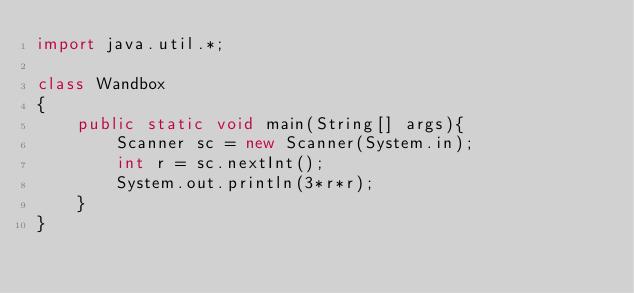Convert code to text. <code><loc_0><loc_0><loc_500><loc_500><_Java_>import java.util.*;

class Wandbox
{
    public static void main(String[] args){
        Scanner sc = new Scanner(System.in);
        int r = sc.nextInt();
        System.out.println(3*r*r);
    }
}
</code> 